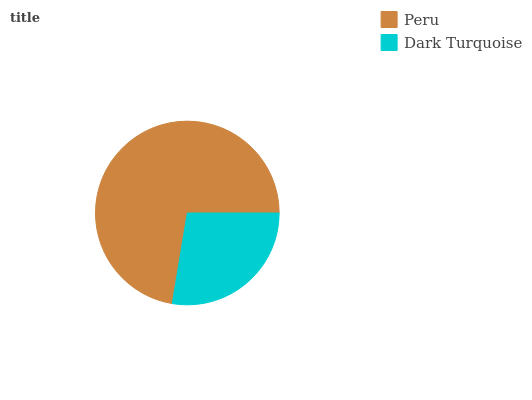Is Dark Turquoise the minimum?
Answer yes or no. Yes. Is Peru the maximum?
Answer yes or no. Yes. Is Dark Turquoise the maximum?
Answer yes or no. No. Is Peru greater than Dark Turquoise?
Answer yes or no. Yes. Is Dark Turquoise less than Peru?
Answer yes or no. Yes. Is Dark Turquoise greater than Peru?
Answer yes or no. No. Is Peru less than Dark Turquoise?
Answer yes or no. No. Is Peru the high median?
Answer yes or no. Yes. Is Dark Turquoise the low median?
Answer yes or no. Yes. Is Dark Turquoise the high median?
Answer yes or no. No. Is Peru the low median?
Answer yes or no. No. 